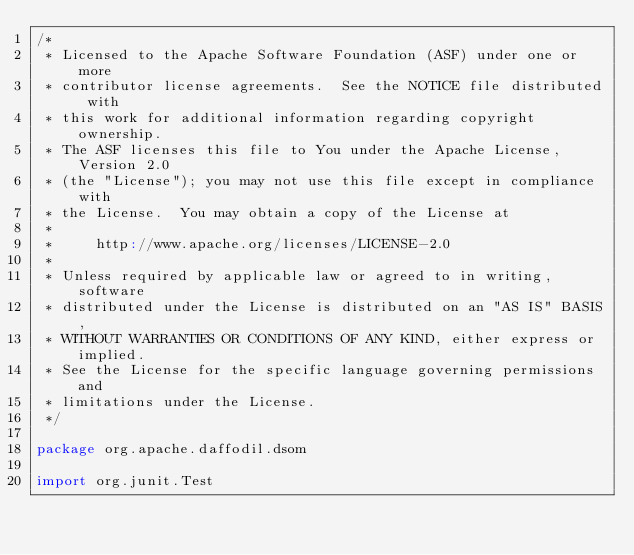Convert code to text. <code><loc_0><loc_0><loc_500><loc_500><_Scala_>/*
 * Licensed to the Apache Software Foundation (ASF) under one or more
 * contributor license agreements.  See the NOTICE file distributed with
 * this work for additional information regarding copyright ownership.
 * The ASF licenses this file to You under the Apache License, Version 2.0
 * (the "License"); you may not use this file except in compliance with
 * the License.  You may obtain a copy of the License at
 *
 *     http://www.apache.org/licenses/LICENSE-2.0
 *
 * Unless required by applicable law or agreed to in writing, software
 * distributed under the License is distributed on an "AS IS" BASIS,
 * WITHOUT WARRANTIES OR CONDITIONS OF ANY KIND, either express or implied.
 * See the License for the specific language governing permissions and
 * limitations under the License.
 */

package org.apache.daffodil.dsom

import org.junit.Test</code> 